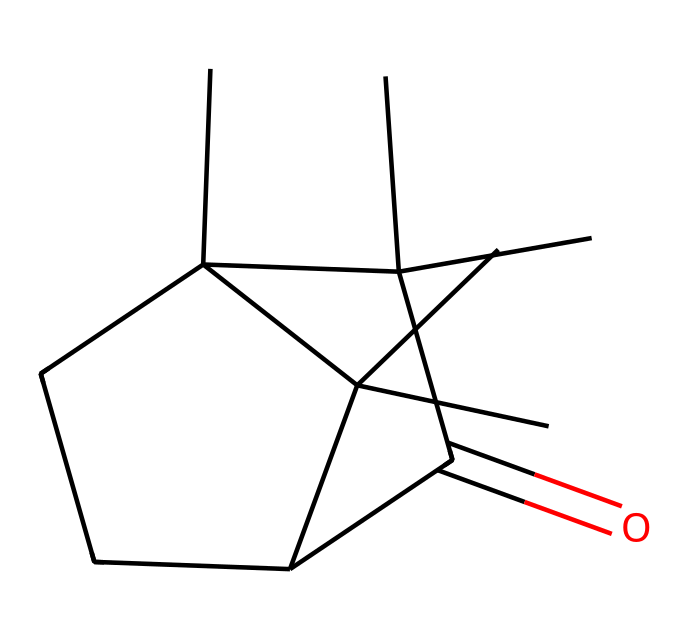what is the name of this compound? The chemical's SMILES structure indicates it contains a carbonyl group (C=O) and multiple carbon atoms arranged in a specific cyclic structure typical of camphor. Therefore, the common name for this compound, as derived from its SMILES representation, is camphor.
Answer: camphor how many carbon atoms are in this compound? By examining the SMILES representation, we can count the number of carbon symbols 'C'. The structure shows a total of 15 carbon atoms present in the molecular arrangement of camphor.
Answer: 15 how many rings are present in this structure? In the SMILES notation, the numbers indicate the start and end of rings. The presence of the numbers '1' and '2' in the structure denotes two rings, confirming that camphor has two distinct cyclic arrangements.
Answer: 2 what type of chemical structure is camphor? Camphor has an aliphatic cyclic structure predominantly due to the arrangement of its carbon atoms in rings and the presence of single bonds, typical of aliphatic compounds.
Answer: aliphatic cyclic what is the characteristic functional group present in camphor? The structure contains a carbonyl group (C=O) highlighted by the part of the molecule with 'C(=O)', defining the distinct functional characteristic of this compound, which is indeed an important functional group.
Answer: carbonyl how many hydrogen atoms are associated with this compound? To determine the number of hydrogen atoms, we can analyze the carbon connectivity and count implicit hydrogens related to each carbon in the structure, valuing the arrangements, which leads us to find that camphor has 24 hydrogen atoms.
Answer: 24 does this compound exhibit stereochemistry? The presence of multiple substituents and rings in the camphor structure introduces the possibility of chiral centers, indicating stereochemistry. The arrangement implies at least one stereocenter leading to this characteristic.
Answer: yes 